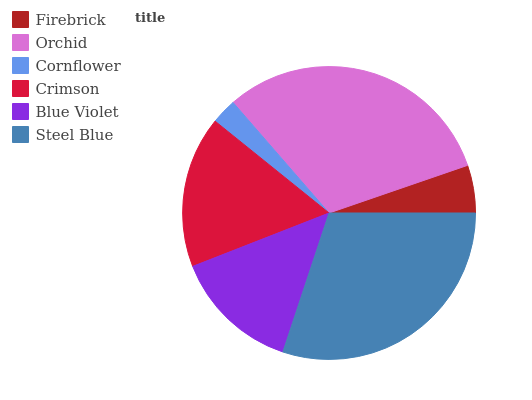Is Cornflower the minimum?
Answer yes or no. Yes. Is Orchid the maximum?
Answer yes or no. Yes. Is Orchid the minimum?
Answer yes or no. No. Is Cornflower the maximum?
Answer yes or no. No. Is Orchid greater than Cornflower?
Answer yes or no. Yes. Is Cornflower less than Orchid?
Answer yes or no. Yes. Is Cornflower greater than Orchid?
Answer yes or no. No. Is Orchid less than Cornflower?
Answer yes or no. No. Is Crimson the high median?
Answer yes or no. Yes. Is Blue Violet the low median?
Answer yes or no. Yes. Is Firebrick the high median?
Answer yes or no. No. Is Cornflower the low median?
Answer yes or no. No. 